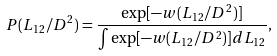<formula> <loc_0><loc_0><loc_500><loc_500>P ( L _ { 1 2 } / D ^ { 2 } ) = \frac { \exp [ - w ( L _ { 1 2 } / D ^ { 2 } ) ] } { \int \exp [ - w ( L _ { 1 2 } / D ^ { 2 } ) ] d L _ { 1 2 } } ,</formula> 